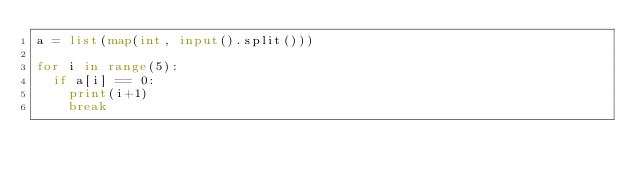Convert code to text. <code><loc_0><loc_0><loc_500><loc_500><_Python_>a = list(map(int, input().split()))

for i in range(5):
  if a[i] == 0:
    print(i+1)
    break</code> 